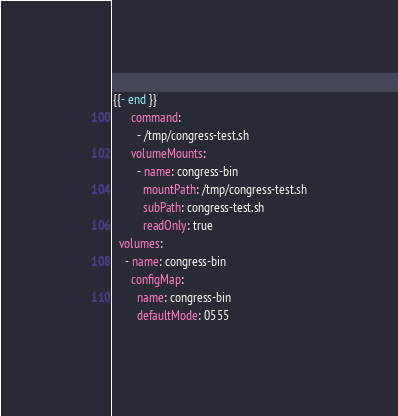<code> <loc_0><loc_0><loc_500><loc_500><_YAML_>{{- end }}
      command:
        - /tmp/congress-test.sh
      volumeMounts:
        - name: congress-bin
          mountPath: /tmp/congress-test.sh
          subPath: congress-test.sh
          readOnly: true
  volumes:
    - name: congress-bin
      configMap:
        name: congress-bin
        defaultMode: 0555
</code> 